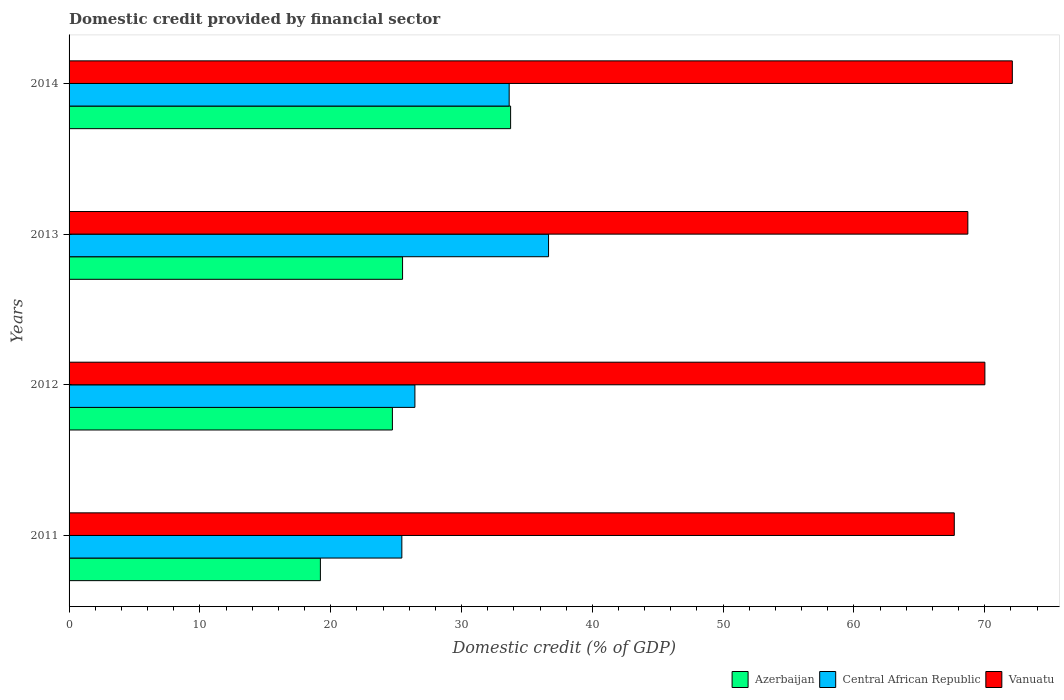How many groups of bars are there?
Offer a terse response. 4. Are the number of bars on each tick of the Y-axis equal?
Your answer should be compact. Yes. How many bars are there on the 2nd tick from the top?
Provide a succinct answer. 3. How many bars are there on the 1st tick from the bottom?
Your answer should be compact. 3. What is the label of the 3rd group of bars from the top?
Your answer should be compact. 2012. In how many cases, is the number of bars for a given year not equal to the number of legend labels?
Keep it short and to the point. 0. What is the domestic credit in Central African Republic in 2014?
Keep it short and to the point. 33.64. Across all years, what is the maximum domestic credit in Central African Republic?
Keep it short and to the point. 36.65. Across all years, what is the minimum domestic credit in Central African Republic?
Your response must be concise. 25.44. What is the total domestic credit in Central African Republic in the graph?
Give a very brief answer. 122.17. What is the difference between the domestic credit in Azerbaijan in 2011 and that in 2012?
Your response must be concise. -5.51. What is the difference between the domestic credit in Azerbaijan in 2014 and the domestic credit in Vanuatu in 2012?
Keep it short and to the point. -36.26. What is the average domestic credit in Vanuatu per year?
Make the answer very short. 69.62. In the year 2013, what is the difference between the domestic credit in Vanuatu and domestic credit in Azerbaijan?
Offer a very short reply. 43.21. What is the ratio of the domestic credit in Central African Republic in 2011 to that in 2012?
Your answer should be compact. 0.96. Is the domestic credit in Vanuatu in 2013 less than that in 2014?
Your response must be concise. Yes. Is the difference between the domestic credit in Vanuatu in 2011 and 2014 greater than the difference between the domestic credit in Azerbaijan in 2011 and 2014?
Keep it short and to the point. Yes. What is the difference between the highest and the second highest domestic credit in Central African Republic?
Provide a short and direct response. 3.01. What is the difference between the highest and the lowest domestic credit in Vanuatu?
Provide a short and direct response. 4.44. In how many years, is the domestic credit in Azerbaijan greater than the average domestic credit in Azerbaijan taken over all years?
Your answer should be compact. 1. What does the 1st bar from the top in 2011 represents?
Your answer should be very brief. Vanuatu. What does the 2nd bar from the bottom in 2014 represents?
Offer a very short reply. Central African Republic. Is it the case that in every year, the sum of the domestic credit in Vanuatu and domestic credit in Azerbaijan is greater than the domestic credit in Central African Republic?
Offer a terse response. Yes. How many bars are there?
Offer a terse response. 12. Are all the bars in the graph horizontal?
Provide a succinct answer. Yes. Are the values on the major ticks of X-axis written in scientific E-notation?
Provide a short and direct response. No. Does the graph contain any zero values?
Offer a terse response. No. Does the graph contain grids?
Provide a succinct answer. No. How many legend labels are there?
Make the answer very short. 3. What is the title of the graph?
Offer a very short reply. Domestic credit provided by financial sector. Does "Korea (Democratic)" appear as one of the legend labels in the graph?
Provide a succinct answer. No. What is the label or title of the X-axis?
Offer a terse response. Domestic credit (% of GDP). What is the label or title of the Y-axis?
Offer a terse response. Years. What is the Domestic credit (% of GDP) of Azerbaijan in 2011?
Ensure brevity in your answer.  19.21. What is the Domestic credit (% of GDP) in Central African Republic in 2011?
Make the answer very short. 25.44. What is the Domestic credit (% of GDP) of Vanuatu in 2011?
Offer a very short reply. 67.67. What is the Domestic credit (% of GDP) in Azerbaijan in 2012?
Your response must be concise. 24.72. What is the Domestic credit (% of GDP) in Central African Republic in 2012?
Make the answer very short. 26.44. What is the Domestic credit (% of GDP) of Vanuatu in 2012?
Provide a succinct answer. 70.01. What is the Domestic credit (% of GDP) in Azerbaijan in 2013?
Your response must be concise. 25.49. What is the Domestic credit (% of GDP) in Central African Republic in 2013?
Offer a terse response. 36.65. What is the Domestic credit (% of GDP) of Vanuatu in 2013?
Offer a terse response. 68.71. What is the Domestic credit (% of GDP) of Azerbaijan in 2014?
Keep it short and to the point. 33.75. What is the Domestic credit (% of GDP) of Central African Republic in 2014?
Your answer should be very brief. 33.64. What is the Domestic credit (% of GDP) of Vanuatu in 2014?
Your answer should be very brief. 72.11. Across all years, what is the maximum Domestic credit (% of GDP) of Azerbaijan?
Provide a short and direct response. 33.75. Across all years, what is the maximum Domestic credit (% of GDP) in Central African Republic?
Offer a terse response. 36.65. Across all years, what is the maximum Domestic credit (% of GDP) of Vanuatu?
Provide a short and direct response. 72.11. Across all years, what is the minimum Domestic credit (% of GDP) in Azerbaijan?
Your answer should be compact. 19.21. Across all years, what is the minimum Domestic credit (% of GDP) in Central African Republic?
Your answer should be compact. 25.44. Across all years, what is the minimum Domestic credit (% of GDP) in Vanuatu?
Provide a succinct answer. 67.67. What is the total Domestic credit (% of GDP) of Azerbaijan in the graph?
Give a very brief answer. 103.18. What is the total Domestic credit (% of GDP) of Central African Republic in the graph?
Your answer should be compact. 122.17. What is the total Domestic credit (% of GDP) in Vanuatu in the graph?
Offer a terse response. 278.49. What is the difference between the Domestic credit (% of GDP) of Azerbaijan in 2011 and that in 2012?
Provide a succinct answer. -5.51. What is the difference between the Domestic credit (% of GDP) in Central African Republic in 2011 and that in 2012?
Ensure brevity in your answer.  -1. What is the difference between the Domestic credit (% of GDP) in Vanuatu in 2011 and that in 2012?
Offer a terse response. -2.34. What is the difference between the Domestic credit (% of GDP) of Azerbaijan in 2011 and that in 2013?
Give a very brief answer. -6.28. What is the difference between the Domestic credit (% of GDP) in Central African Republic in 2011 and that in 2013?
Give a very brief answer. -11.21. What is the difference between the Domestic credit (% of GDP) of Vanuatu in 2011 and that in 2013?
Your answer should be compact. -1.04. What is the difference between the Domestic credit (% of GDP) of Azerbaijan in 2011 and that in 2014?
Offer a terse response. -14.54. What is the difference between the Domestic credit (% of GDP) of Central African Republic in 2011 and that in 2014?
Your answer should be compact. -8.21. What is the difference between the Domestic credit (% of GDP) of Vanuatu in 2011 and that in 2014?
Ensure brevity in your answer.  -4.44. What is the difference between the Domestic credit (% of GDP) of Azerbaijan in 2012 and that in 2013?
Your answer should be very brief. -0.78. What is the difference between the Domestic credit (% of GDP) of Central African Republic in 2012 and that in 2013?
Provide a short and direct response. -10.22. What is the difference between the Domestic credit (% of GDP) of Vanuatu in 2012 and that in 2013?
Your response must be concise. 1.3. What is the difference between the Domestic credit (% of GDP) in Azerbaijan in 2012 and that in 2014?
Give a very brief answer. -9.04. What is the difference between the Domestic credit (% of GDP) of Central African Republic in 2012 and that in 2014?
Offer a terse response. -7.21. What is the difference between the Domestic credit (% of GDP) in Vanuatu in 2012 and that in 2014?
Make the answer very short. -2.1. What is the difference between the Domestic credit (% of GDP) of Azerbaijan in 2013 and that in 2014?
Your response must be concise. -8.26. What is the difference between the Domestic credit (% of GDP) in Central African Republic in 2013 and that in 2014?
Your response must be concise. 3.01. What is the difference between the Domestic credit (% of GDP) in Vanuatu in 2013 and that in 2014?
Your answer should be compact. -3.4. What is the difference between the Domestic credit (% of GDP) of Azerbaijan in 2011 and the Domestic credit (% of GDP) of Central African Republic in 2012?
Ensure brevity in your answer.  -7.23. What is the difference between the Domestic credit (% of GDP) of Azerbaijan in 2011 and the Domestic credit (% of GDP) of Vanuatu in 2012?
Your answer should be compact. -50.8. What is the difference between the Domestic credit (% of GDP) in Central African Republic in 2011 and the Domestic credit (% of GDP) in Vanuatu in 2012?
Your response must be concise. -44.57. What is the difference between the Domestic credit (% of GDP) of Azerbaijan in 2011 and the Domestic credit (% of GDP) of Central African Republic in 2013?
Provide a short and direct response. -17.44. What is the difference between the Domestic credit (% of GDP) in Azerbaijan in 2011 and the Domestic credit (% of GDP) in Vanuatu in 2013?
Give a very brief answer. -49.49. What is the difference between the Domestic credit (% of GDP) in Central African Republic in 2011 and the Domestic credit (% of GDP) in Vanuatu in 2013?
Make the answer very short. -43.27. What is the difference between the Domestic credit (% of GDP) of Azerbaijan in 2011 and the Domestic credit (% of GDP) of Central African Republic in 2014?
Ensure brevity in your answer.  -14.43. What is the difference between the Domestic credit (% of GDP) of Azerbaijan in 2011 and the Domestic credit (% of GDP) of Vanuatu in 2014?
Your answer should be compact. -52.9. What is the difference between the Domestic credit (% of GDP) in Central African Republic in 2011 and the Domestic credit (% of GDP) in Vanuatu in 2014?
Ensure brevity in your answer.  -46.67. What is the difference between the Domestic credit (% of GDP) of Azerbaijan in 2012 and the Domestic credit (% of GDP) of Central African Republic in 2013?
Offer a very short reply. -11.94. What is the difference between the Domestic credit (% of GDP) of Azerbaijan in 2012 and the Domestic credit (% of GDP) of Vanuatu in 2013?
Ensure brevity in your answer.  -43.99. What is the difference between the Domestic credit (% of GDP) in Central African Republic in 2012 and the Domestic credit (% of GDP) in Vanuatu in 2013?
Make the answer very short. -42.27. What is the difference between the Domestic credit (% of GDP) of Azerbaijan in 2012 and the Domestic credit (% of GDP) of Central African Republic in 2014?
Your answer should be very brief. -8.93. What is the difference between the Domestic credit (% of GDP) of Azerbaijan in 2012 and the Domestic credit (% of GDP) of Vanuatu in 2014?
Your response must be concise. -47.39. What is the difference between the Domestic credit (% of GDP) of Central African Republic in 2012 and the Domestic credit (% of GDP) of Vanuatu in 2014?
Your answer should be very brief. -45.67. What is the difference between the Domestic credit (% of GDP) of Azerbaijan in 2013 and the Domestic credit (% of GDP) of Central African Republic in 2014?
Your answer should be very brief. -8.15. What is the difference between the Domestic credit (% of GDP) of Azerbaijan in 2013 and the Domestic credit (% of GDP) of Vanuatu in 2014?
Offer a very short reply. -46.61. What is the difference between the Domestic credit (% of GDP) of Central African Republic in 2013 and the Domestic credit (% of GDP) of Vanuatu in 2014?
Provide a short and direct response. -35.45. What is the average Domestic credit (% of GDP) of Azerbaijan per year?
Ensure brevity in your answer.  25.79. What is the average Domestic credit (% of GDP) of Central African Republic per year?
Give a very brief answer. 30.54. What is the average Domestic credit (% of GDP) in Vanuatu per year?
Ensure brevity in your answer.  69.62. In the year 2011, what is the difference between the Domestic credit (% of GDP) of Azerbaijan and Domestic credit (% of GDP) of Central African Republic?
Make the answer very short. -6.23. In the year 2011, what is the difference between the Domestic credit (% of GDP) in Azerbaijan and Domestic credit (% of GDP) in Vanuatu?
Offer a terse response. -48.46. In the year 2011, what is the difference between the Domestic credit (% of GDP) of Central African Republic and Domestic credit (% of GDP) of Vanuatu?
Keep it short and to the point. -42.23. In the year 2012, what is the difference between the Domestic credit (% of GDP) in Azerbaijan and Domestic credit (% of GDP) in Central African Republic?
Ensure brevity in your answer.  -1.72. In the year 2012, what is the difference between the Domestic credit (% of GDP) in Azerbaijan and Domestic credit (% of GDP) in Vanuatu?
Provide a succinct answer. -45.29. In the year 2012, what is the difference between the Domestic credit (% of GDP) in Central African Republic and Domestic credit (% of GDP) in Vanuatu?
Provide a succinct answer. -43.57. In the year 2013, what is the difference between the Domestic credit (% of GDP) in Azerbaijan and Domestic credit (% of GDP) in Central African Republic?
Offer a terse response. -11.16. In the year 2013, what is the difference between the Domestic credit (% of GDP) of Azerbaijan and Domestic credit (% of GDP) of Vanuatu?
Offer a terse response. -43.21. In the year 2013, what is the difference between the Domestic credit (% of GDP) in Central African Republic and Domestic credit (% of GDP) in Vanuatu?
Make the answer very short. -32.05. In the year 2014, what is the difference between the Domestic credit (% of GDP) of Azerbaijan and Domestic credit (% of GDP) of Central African Republic?
Provide a succinct answer. 0.11. In the year 2014, what is the difference between the Domestic credit (% of GDP) in Azerbaijan and Domestic credit (% of GDP) in Vanuatu?
Ensure brevity in your answer.  -38.35. In the year 2014, what is the difference between the Domestic credit (% of GDP) of Central African Republic and Domestic credit (% of GDP) of Vanuatu?
Offer a terse response. -38.46. What is the ratio of the Domestic credit (% of GDP) in Azerbaijan in 2011 to that in 2012?
Offer a very short reply. 0.78. What is the ratio of the Domestic credit (% of GDP) in Central African Republic in 2011 to that in 2012?
Give a very brief answer. 0.96. What is the ratio of the Domestic credit (% of GDP) of Vanuatu in 2011 to that in 2012?
Give a very brief answer. 0.97. What is the ratio of the Domestic credit (% of GDP) of Azerbaijan in 2011 to that in 2013?
Offer a very short reply. 0.75. What is the ratio of the Domestic credit (% of GDP) of Central African Republic in 2011 to that in 2013?
Your answer should be very brief. 0.69. What is the ratio of the Domestic credit (% of GDP) of Vanuatu in 2011 to that in 2013?
Ensure brevity in your answer.  0.98. What is the ratio of the Domestic credit (% of GDP) in Azerbaijan in 2011 to that in 2014?
Provide a succinct answer. 0.57. What is the ratio of the Domestic credit (% of GDP) of Central African Republic in 2011 to that in 2014?
Your answer should be very brief. 0.76. What is the ratio of the Domestic credit (% of GDP) in Vanuatu in 2011 to that in 2014?
Ensure brevity in your answer.  0.94. What is the ratio of the Domestic credit (% of GDP) in Azerbaijan in 2012 to that in 2013?
Provide a succinct answer. 0.97. What is the ratio of the Domestic credit (% of GDP) in Central African Republic in 2012 to that in 2013?
Offer a very short reply. 0.72. What is the ratio of the Domestic credit (% of GDP) of Vanuatu in 2012 to that in 2013?
Make the answer very short. 1.02. What is the ratio of the Domestic credit (% of GDP) of Azerbaijan in 2012 to that in 2014?
Your answer should be very brief. 0.73. What is the ratio of the Domestic credit (% of GDP) of Central African Republic in 2012 to that in 2014?
Your response must be concise. 0.79. What is the ratio of the Domestic credit (% of GDP) of Vanuatu in 2012 to that in 2014?
Provide a short and direct response. 0.97. What is the ratio of the Domestic credit (% of GDP) of Azerbaijan in 2013 to that in 2014?
Your answer should be very brief. 0.76. What is the ratio of the Domestic credit (% of GDP) in Central African Republic in 2013 to that in 2014?
Provide a succinct answer. 1.09. What is the ratio of the Domestic credit (% of GDP) of Vanuatu in 2013 to that in 2014?
Provide a succinct answer. 0.95. What is the difference between the highest and the second highest Domestic credit (% of GDP) in Azerbaijan?
Your response must be concise. 8.26. What is the difference between the highest and the second highest Domestic credit (% of GDP) in Central African Republic?
Provide a short and direct response. 3.01. What is the difference between the highest and the second highest Domestic credit (% of GDP) in Vanuatu?
Your answer should be compact. 2.1. What is the difference between the highest and the lowest Domestic credit (% of GDP) of Azerbaijan?
Offer a very short reply. 14.54. What is the difference between the highest and the lowest Domestic credit (% of GDP) in Central African Republic?
Keep it short and to the point. 11.21. What is the difference between the highest and the lowest Domestic credit (% of GDP) of Vanuatu?
Your response must be concise. 4.44. 